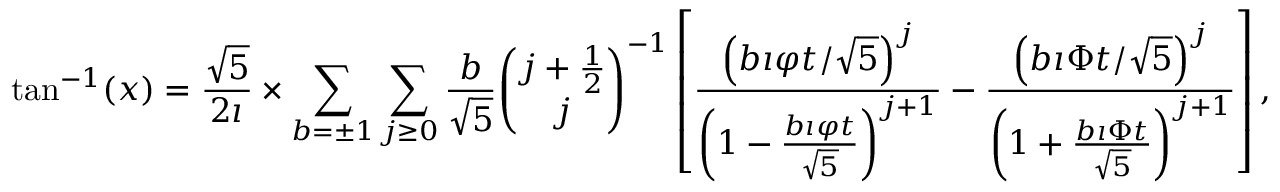<formula> <loc_0><loc_0><loc_500><loc_500>\tan ^ { - 1 } ( x ) = { \frac { \sqrt { 5 } } { 2 \imath } } \times \sum _ { b = \pm 1 } \sum _ { j \geq 0 } { \frac { b } { \sqrt { 5 } } } { \binom { j + { \frac { 1 } { 2 } } } { j } } ^ { - 1 } \left [ { \frac { \left ( b \imath \varphi t / { \sqrt { 5 } } \right ) ^ { j } } { \left ( 1 - { \frac { b \imath \varphi t } { \sqrt { 5 } } } \right ) ^ { j + 1 } } } - { \frac { \left ( b \imath \Phi t / { \sqrt { 5 } } \right ) ^ { j } } { \left ( 1 + { \frac { b \imath \Phi t } { \sqrt { 5 } } } \right ) ^ { j + 1 } } } \right ] ,</formula> 